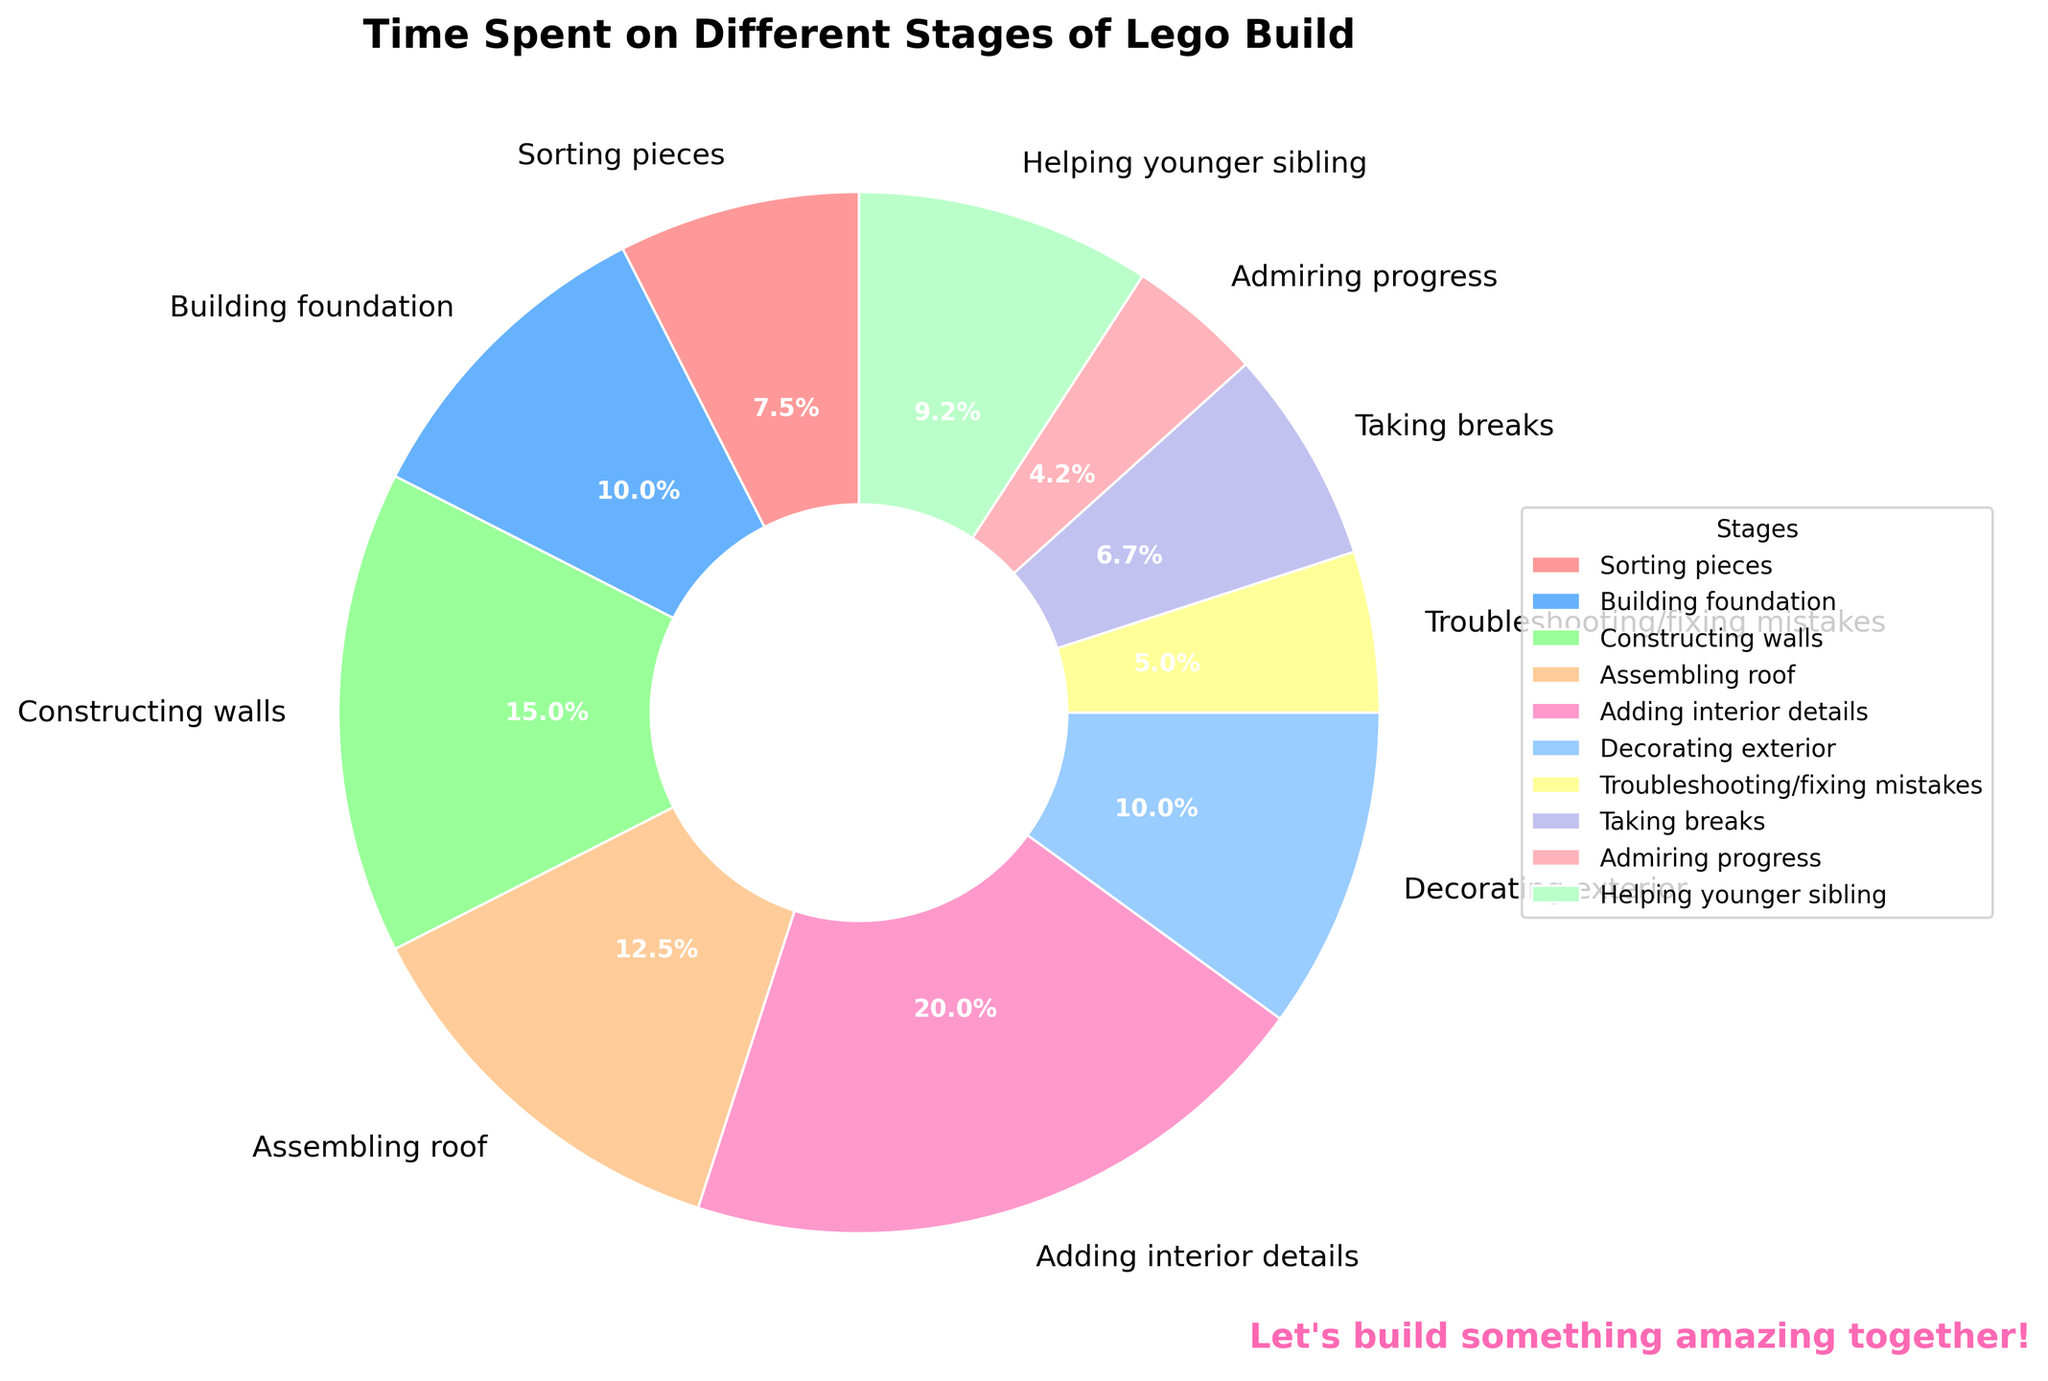What's the largest segment in the pie chart? Look for the segment that has the most substantial area in the pie chart, which represents the largest time spent on a particular stage. The "Adding interior details" segment is the largest.
Answer: Adding interior details Which two stages together consume the most time? Identify the two largest segments and sum their times. "Adding interior details" (120 minutes) and "Constructing walls" (90 minutes) together consume the most time: 120 + 90 = 210 minutes.
Answer: Adding interior details and Constructing walls How much time is spent on tasks other than the main building stages (e.g., Sorting pieces, Building foundation, Constructing walls, Assembling roof)? Calculate the total time spent on non-core activities: Sorting pieces (45), Troubleshooting/fixing mistakes (30), Taking breaks (40), Admiring progress (25), Helping younger sibling (55), and Decorating exterior (60). Sum them up: 45 + 30 + 40 + 25 + 55 + 60 = 255 minutes.
Answer: 255 minutes Which stage consumes more time: "Building foundation" or "Assembling roof"? By how many minutes? Look at the time spent on each stage. "Building foundation" is 60 minutes, while "Assembling roof" is 75 minutes. The difference is 75 - 60 = 15 minutes.
Answer: Assembling roof by 15 minutes What percentage of the total time is spent on "Helping younger sibling"? The total time is the sum of all the times: 45 + 60 + 90 + 75 + 120 + 60 + 30 + 40 + 25 + 55 = 600 minutes. The "Helping younger sibling" stage is 55 minutes. Calculate its percentage: (55/600) * 100 = 9.17%.
Answer: 9.17% Compare the time spent on "Taking breaks" to "Admiring progress". Which stage takes more time, and is it more or less than double? "Taking breaks" is 40 minutes, while "Admiring progress" is 25 minutes. Comparing them, 40 minutes is more than 25 minutes. To check if it's more than double, see if 40 > 2 * 25. Since 40 is indeed greater than 50, the time spent on "Taking breaks" is not more than double "Admiring progress."
Answer: Taking breaks, not more than double If you had an hour left to work on the Lego build, which remaining stage would you spend that time on to have the biggest impact? Identify which remaining stages would benefit the most from additional time: "Adding interior details" (120 minutes) and "Constructing walls" (90 minutes) are the stages that require the most time. To maximize impact, spending time on "Adding interior details" would be the best option.
Answer: Adding interior details What do the colors in the pie chart signify? The colors visually differentiate each stage of the Lego building process, making it easier to distinguish between the different segments and understand the distribution of time spent on each stage.
Answer: Differentiating stages How does the time spent on "Decorating exterior" compare to that of "Building foundation"? "Decorating exterior" takes 60 minutes, while "Building foundation" also takes 60 minutes, indicating they consume equal time.
Answer: Equal time What is the total time spent on stages related to finishing touches (e.g., adding interior details, decorating exterior, admiring progress)? Add the times for "Adding interior details" (120 minutes), "Decorating exterior" (60 minutes), and "Admiring progress" (25 minutes): 120 + 60 + 25 = 205 minutes.
Answer: 205 minutes 